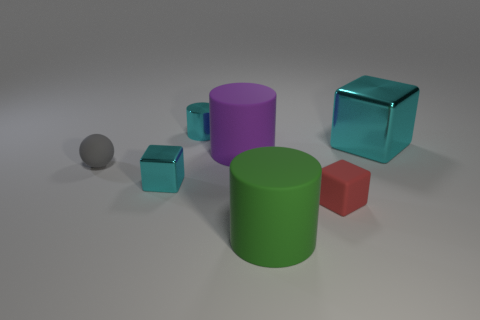There is a small shiny thing behind the big object right of the large rubber cylinder in front of the small cyan shiny cube; what color is it?
Offer a very short reply. Cyan. There is a shiny block that is the same size as the green cylinder; what color is it?
Provide a short and direct response. Cyan. What shape is the big rubber thing that is in front of the tiny block to the right of the small cyan shiny thing that is behind the large cyan metallic thing?
Your answer should be compact. Cylinder. There is a big metal thing that is the same color as the small metallic cylinder; what is its shape?
Your response must be concise. Cube. What number of objects are either small gray spheres or large rubber objects that are behind the green rubber cylinder?
Your answer should be very brief. 2. Does the cylinder that is behind the purple rubber cylinder have the same size as the small red rubber object?
Offer a terse response. Yes. What is the material of the ball that is on the left side of the green matte cylinder?
Provide a succinct answer. Rubber. Are there an equal number of big green objects to the right of the red matte object and purple rubber cylinders to the right of the large block?
Provide a succinct answer. Yes. There is another large rubber thing that is the same shape as the big green thing; what is its color?
Offer a very short reply. Purple. Is there anything else of the same color as the tiny metal cylinder?
Your answer should be compact. Yes. 